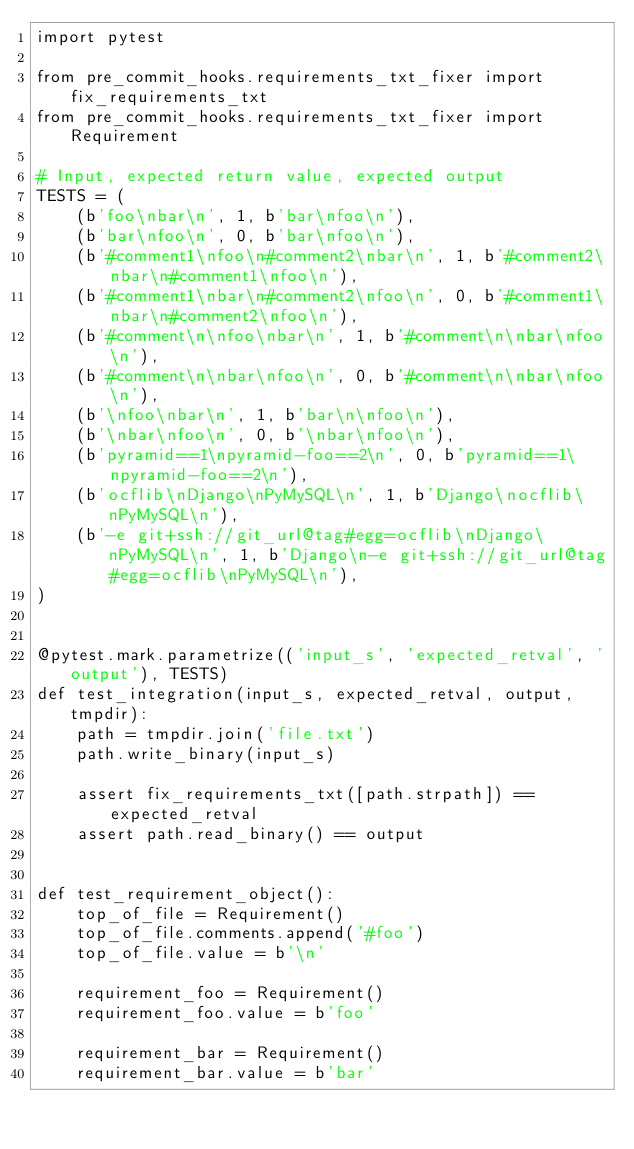Convert code to text. <code><loc_0><loc_0><loc_500><loc_500><_Python_>import pytest

from pre_commit_hooks.requirements_txt_fixer import fix_requirements_txt
from pre_commit_hooks.requirements_txt_fixer import Requirement

# Input, expected return value, expected output
TESTS = (
    (b'foo\nbar\n', 1, b'bar\nfoo\n'),
    (b'bar\nfoo\n', 0, b'bar\nfoo\n'),
    (b'#comment1\nfoo\n#comment2\nbar\n', 1, b'#comment2\nbar\n#comment1\nfoo\n'),
    (b'#comment1\nbar\n#comment2\nfoo\n', 0, b'#comment1\nbar\n#comment2\nfoo\n'),
    (b'#comment\n\nfoo\nbar\n', 1, b'#comment\n\nbar\nfoo\n'),
    (b'#comment\n\nbar\nfoo\n', 0, b'#comment\n\nbar\nfoo\n'),
    (b'\nfoo\nbar\n', 1, b'bar\n\nfoo\n'),
    (b'\nbar\nfoo\n', 0, b'\nbar\nfoo\n'),
    (b'pyramid==1\npyramid-foo==2\n', 0, b'pyramid==1\npyramid-foo==2\n'),
    (b'ocflib\nDjango\nPyMySQL\n', 1, b'Django\nocflib\nPyMySQL\n'),
    (b'-e git+ssh://git_url@tag#egg=ocflib\nDjango\nPyMySQL\n', 1, b'Django\n-e git+ssh://git_url@tag#egg=ocflib\nPyMySQL\n'),
)


@pytest.mark.parametrize(('input_s', 'expected_retval', 'output'), TESTS)
def test_integration(input_s, expected_retval, output, tmpdir):
    path = tmpdir.join('file.txt')
    path.write_binary(input_s)

    assert fix_requirements_txt([path.strpath]) == expected_retval
    assert path.read_binary() == output


def test_requirement_object():
    top_of_file = Requirement()
    top_of_file.comments.append('#foo')
    top_of_file.value = b'\n'

    requirement_foo = Requirement()
    requirement_foo.value = b'foo'

    requirement_bar = Requirement()
    requirement_bar.value = b'bar'
</code> 